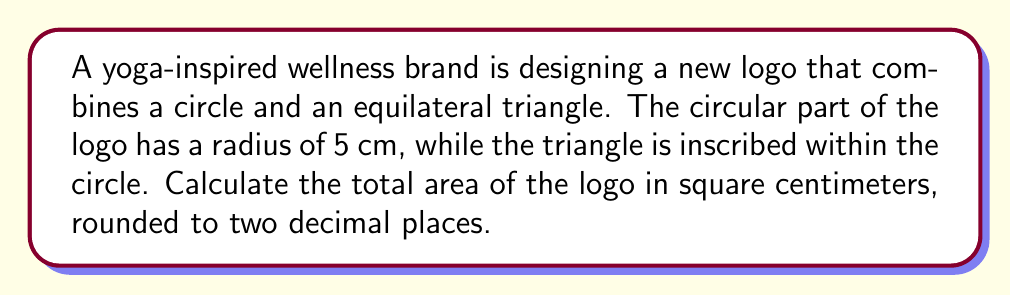Provide a solution to this math problem. Let's approach this step-by-step:

1) First, we need to calculate the area of the circle:
   $$A_{circle} = \pi r^2 = \pi (5\text{ cm})^2 = 25\pi \text{ cm}^2$$

2) Now, for the inscribed equilateral triangle:
   The radius of the circle bisects one side of the triangle, creating a 30-60-90 triangle.
   
   [asy]
   import geometry;
   
   size(100);
   pair O=(0,0);
   pair A=(0,5);
   pair B=rotate(120)*A;
   pair C=rotate(240)*A;
   
   draw(circle(O,5));
   draw(A--B--C--cycle);
   draw(O--A);
   
   label("O",O,SW);
   label("A",A,N);
   label("B",B,SW);
   label("C",C,SE);
   label("r",O--A,E);
   label("a/2",(O+A)/2,W);
   [/asy]

3) In a 30-60-90 triangle, if the hypotenuse (radius) is r, the shorter leg (half of the triangle's side) is $r\frac{\sqrt{3}}{2}$.

4) So, the side length of the equilateral triangle is:
   $$a = 2 \cdot 5\text{ cm} \cdot \frac{\sqrt{3}}{2} = 5\sqrt{3}\text{ cm}$$

5) The area of an equilateral triangle with side length a is:
   $$A_{triangle} = \frac{\sqrt{3}}{4}a^2 = \frac{\sqrt{3}}{4}(5\sqrt{3}\text{ cm})^2 = \frac{75\sqrt{3}}{4}\text{ cm}^2$$

6) The total area is the sum of both shapes:
   $$A_{total} = A_{circle} + A_{triangle} = 25\pi \text{ cm}^2 + \frac{75\sqrt{3}}{4}\text{ cm}^2$$

7) Calculating this numerically:
   $$A_{total} \approx 78.54 \text{ cm}^2 + 32.48 \text{ cm}^2 = 111.02 \text{ cm}^2$$

Therefore, the total area of the logo, rounded to two decimal places, is 111.02 cm².
Answer: 111.02 cm² 